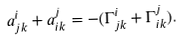Convert formula to latex. <formula><loc_0><loc_0><loc_500><loc_500>a _ { j k } ^ { i } + a _ { i k } ^ { j } = - ( \Gamma _ { j k } ^ { i } + \Gamma _ { i k } ^ { j } ) .</formula> 